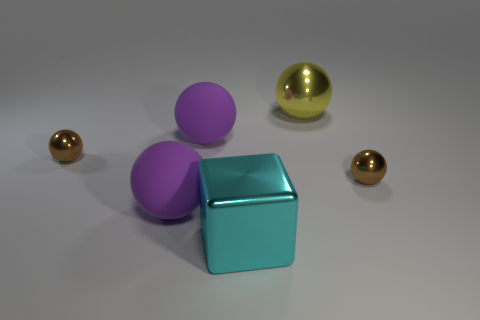Subtract all small spheres. How many spheres are left? 3 Add 3 small shiny objects. How many objects exist? 9 Subtract all purple spheres. How many spheres are left? 3 Subtract all spheres. How many objects are left? 1 Subtract 1 cubes. How many cubes are left? 0 Subtract all gray cubes. How many yellow balls are left? 1 Add 4 big purple things. How many big purple things are left? 6 Add 4 cyan things. How many cyan things exist? 5 Subtract 0 red blocks. How many objects are left? 6 Subtract all yellow balls. Subtract all gray cylinders. How many balls are left? 4 